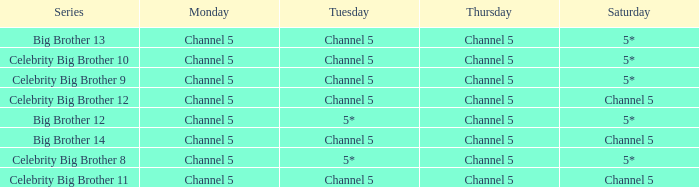Which Tuesday does big brother 12 air? 5*. 